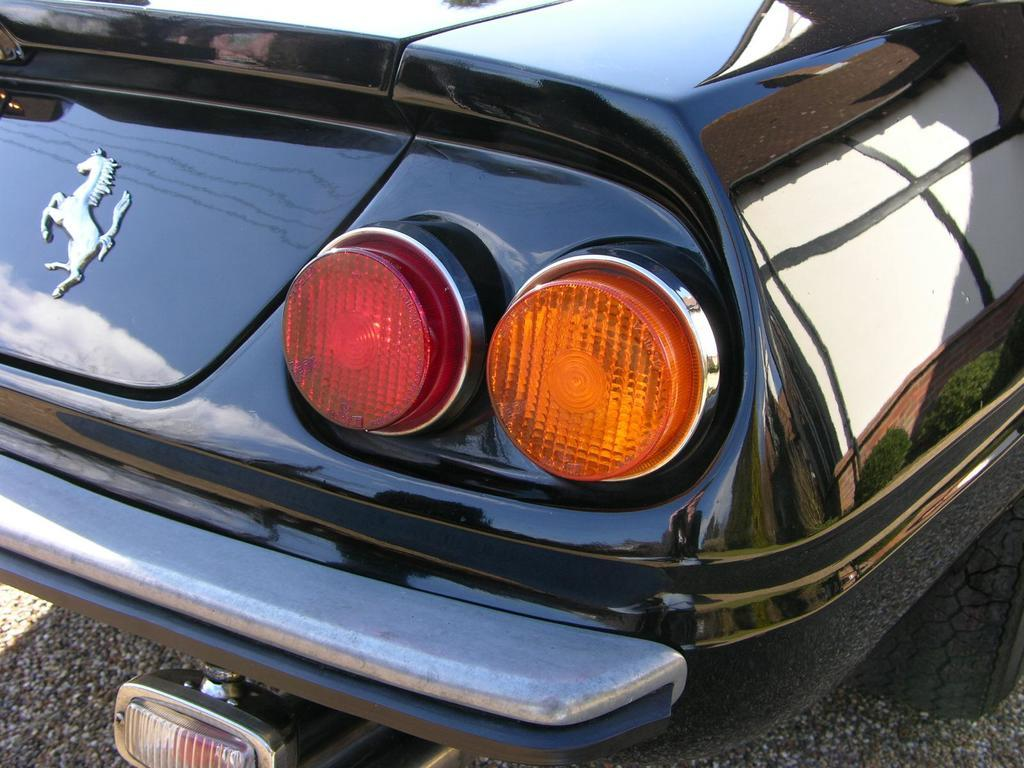What type of motor vehicle is in the image? The specific type of motor vehicle is not mentioned, but it is present in the image. Where is the motor vehicle located? The motor vehicle is on the road. What color is the nail that the geese are holding in the image? There are no geese or nails present in the image; it only features a motor vehicle on the road. 